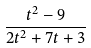Convert formula to latex. <formula><loc_0><loc_0><loc_500><loc_500>\frac { t ^ { 2 } - 9 } { 2 t ^ { 2 } + 7 t + 3 }</formula> 